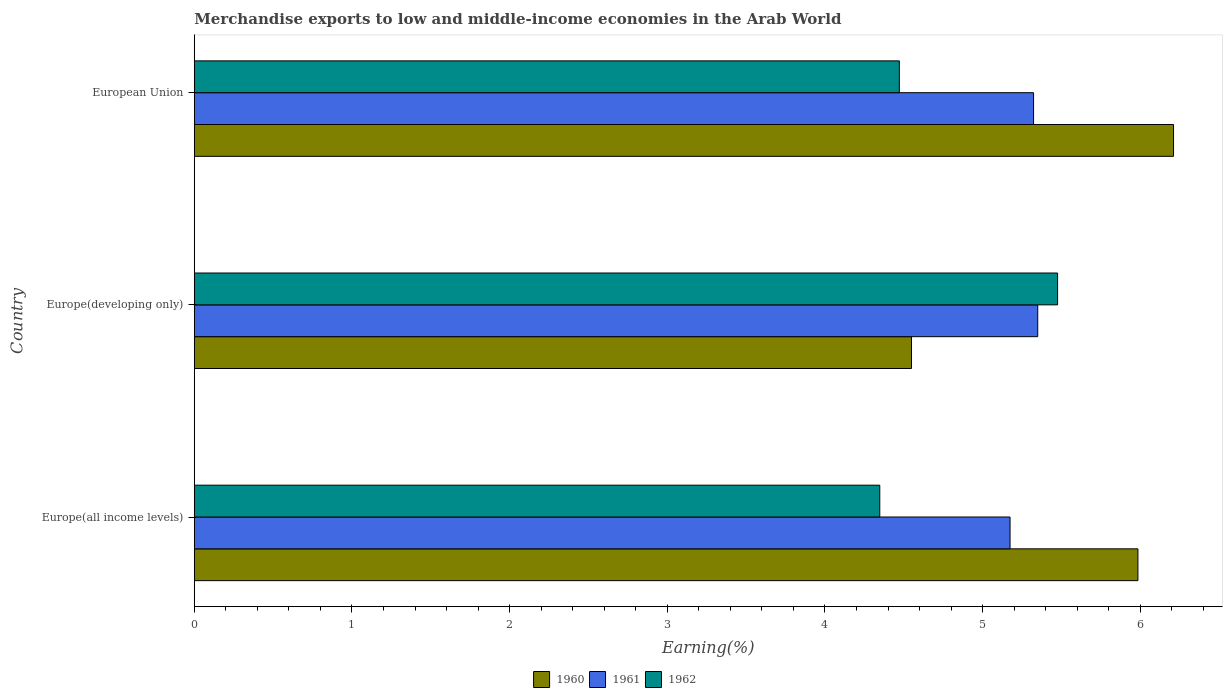How many different coloured bars are there?
Give a very brief answer. 3. How many groups of bars are there?
Provide a succinct answer. 3. Are the number of bars per tick equal to the number of legend labels?
Offer a very short reply. Yes. Are the number of bars on each tick of the Y-axis equal?
Ensure brevity in your answer.  Yes. How many bars are there on the 1st tick from the bottom?
Offer a very short reply. 3. In how many cases, is the number of bars for a given country not equal to the number of legend labels?
Keep it short and to the point. 0. What is the percentage of amount earned from merchandise exports in 1962 in Europe(all income levels)?
Give a very brief answer. 4.35. Across all countries, what is the maximum percentage of amount earned from merchandise exports in 1961?
Offer a very short reply. 5.35. Across all countries, what is the minimum percentage of amount earned from merchandise exports in 1962?
Keep it short and to the point. 4.35. In which country was the percentage of amount earned from merchandise exports in 1960 minimum?
Offer a very short reply. Europe(developing only). What is the total percentage of amount earned from merchandise exports in 1960 in the graph?
Your answer should be compact. 16.74. What is the difference between the percentage of amount earned from merchandise exports in 1960 in Europe(all income levels) and that in Europe(developing only)?
Provide a short and direct response. 1.44. What is the difference between the percentage of amount earned from merchandise exports in 1961 in Europe(developing only) and the percentage of amount earned from merchandise exports in 1962 in Europe(all income levels)?
Make the answer very short. 1. What is the average percentage of amount earned from merchandise exports in 1962 per country?
Offer a very short reply. 4.76. What is the difference between the percentage of amount earned from merchandise exports in 1962 and percentage of amount earned from merchandise exports in 1961 in European Union?
Your response must be concise. -0.85. What is the ratio of the percentage of amount earned from merchandise exports in 1961 in Europe(all income levels) to that in Europe(developing only)?
Provide a succinct answer. 0.97. Is the percentage of amount earned from merchandise exports in 1960 in Europe(all income levels) less than that in Europe(developing only)?
Ensure brevity in your answer.  No. What is the difference between the highest and the second highest percentage of amount earned from merchandise exports in 1962?
Provide a short and direct response. 1. What is the difference between the highest and the lowest percentage of amount earned from merchandise exports in 1962?
Your answer should be very brief. 1.13. Is the sum of the percentage of amount earned from merchandise exports in 1961 in Europe(developing only) and European Union greater than the maximum percentage of amount earned from merchandise exports in 1960 across all countries?
Provide a short and direct response. Yes. What does the 1st bar from the top in European Union represents?
Give a very brief answer. 1962. What does the 1st bar from the bottom in Europe(developing only) represents?
Provide a short and direct response. 1960. Is it the case that in every country, the sum of the percentage of amount earned from merchandise exports in 1960 and percentage of amount earned from merchandise exports in 1961 is greater than the percentage of amount earned from merchandise exports in 1962?
Give a very brief answer. Yes. How many bars are there?
Provide a succinct answer. 9. Are the values on the major ticks of X-axis written in scientific E-notation?
Provide a succinct answer. No. Does the graph contain grids?
Your answer should be very brief. No. Where does the legend appear in the graph?
Keep it short and to the point. Bottom center. How many legend labels are there?
Make the answer very short. 3. What is the title of the graph?
Your response must be concise. Merchandise exports to low and middle-income economies in the Arab World. What is the label or title of the X-axis?
Keep it short and to the point. Earning(%). What is the Earning(%) in 1960 in Europe(all income levels)?
Ensure brevity in your answer.  5.98. What is the Earning(%) in 1961 in Europe(all income levels)?
Offer a terse response. 5.17. What is the Earning(%) in 1962 in Europe(all income levels)?
Your answer should be compact. 4.35. What is the Earning(%) in 1960 in Europe(developing only)?
Offer a very short reply. 4.55. What is the Earning(%) of 1961 in Europe(developing only)?
Provide a succinct answer. 5.35. What is the Earning(%) of 1962 in Europe(developing only)?
Offer a terse response. 5.48. What is the Earning(%) in 1960 in European Union?
Your response must be concise. 6.21. What is the Earning(%) of 1961 in European Union?
Keep it short and to the point. 5.32. What is the Earning(%) in 1962 in European Union?
Your response must be concise. 4.47. Across all countries, what is the maximum Earning(%) in 1960?
Your answer should be very brief. 6.21. Across all countries, what is the maximum Earning(%) in 1961?
Your response must be concise. 5.35. Across all countries, what is the maximum Earning(%) of 1962?
Keep it short and to the point. 5.48. Across all countries, what is the minimum Earning(%) of 1960?
Provide a succinct answer. 4.55. Across all countries, what is the minimum Earning(%) in 1961?
Your response must be concise. 5.17. Across all countries, what is the minimum Earning(%) of 1962?
Your response must be concise. 4.35. What is the total Earning(%) of 1960 in the graph?
Make the answer very short. 16.74. What is the total Earning(%) of 1961 in the graph?
Provide a short and direct response. 15.85. What is the total Earning(%) of 1962 in the graph?
Give a very brief answer. 14.29. What is the difference between the Earning(%) of 1960 in Europe(all income levels) and that in Europe(developing only)?
Provide a short and direct response. 1.44. What is the difference between the Earning(%) of 1961 in Europe(all income levels) and that in Europe(developing only)?
Provide a succinct answer. -0.18. What is the difference between the Earning(%) of 1962 in Europe(all income levels) and that in Europe(developing only)?
Your answer should be very brief. -1.13. What is the difference between the Earning(%) in 1960 in Europe(all income levels) and that in European Union?
Keep it short and to the point. -0.23. What is the difference between the Earning(%) of 1961 in Europe(all income levels) and that in European Union?
Your response must be concise. -0.15. What is the difference between the Earning(%) in 1962 in Europe(all income levels) and that in European Union?
Offer a very short reply. -0.12. What is the difference between the Earning(%) of 1960 in Europe(developing only) and that in European Union?
Ensure brevity in your answer.  -1.66. What is the difference between the Earning(%) in 1961 in Europe(developing only) and that in European Union?
Provide a short and direct response. 0.03. What is the difference between the Earning(%) in 1962 in Europe(developing only) and that in European Union?
Provide a short and direct response. 1. What is the difference between the Earning(%) in 1960 in Europe(all income levels) and the Earning(%) in 1961 in Europe(developing only)?
Provide a succinct answer. 0.64. What is the difference between the Earning(%) in 1960 in Europe(all income levels) and the Earning(%) in 1962 in Europe(developing only)?
Keep it short and to the point. 0.51. What is the difference between the Earning(%) of 1961 in Europe(all income levels) and the Earning(%) of 1962 in Europe(developing only)?
Ensure brevity in your answer.  -0.3. What is the difference between the Earning(%) of 1960 in Europe(all income levels) and the Earning(%) of 1961 in European Union?
Give a very brief answer. 0.66. What is the difference between the Earning(%) in 1960 in Europe(all income levels) and the Earning(%) in 1962 in European Union?
Provide a short and direct response. 1.51. What is the difference between the Earning(%) of 1961 in Europe(all income levels) and the Earning(%) of 1962 in European Union?
Give a very brief answer. 0.7. What is the difference between the Earning(%) in 1960 in Europe(developing only) and the Earning(%) in 1961 in European Union?
Your response must be concise. -0.77. What is the difference between the Earning(%) in 1960 in Europe(developing only) and the Earning(%) in 1962 in European Union?
Keep it short and to the point. 0.08. What is the difference between the Earning(%) of 1961 in Europe(developing only) and the Earning(%) of 1962 in European Union?
Your response must be concise. 0.88. What is the average Earning(%) of 1960 per country?
Your answer should be very brief. 5.58. What is the average Earning(%) of 1961 per country?
Your answer should be compact. 5.28. What is the average Earning(%) in 1962 per country?
Provide a short and direct response. 4.76. What is the difference between the Earning(%) of 1960 and Earning(%) of 1961 in Europe(all income levels)?
Keep it short and to the point. 0.81. What is the difference between the Earning(%) of 1960 and Earning(%) of 1962 in Europe(all income levels)?
Offer a very short reply. 1.64. What is the difference between the Earning(%) of 1961 and Earning(%) of 1962 in Europe(all income levels)?
Offer a very short reply. 0.83. What is the difference between the Earning(%) of 1960 and Earning(%) of 1961 in Europe(developing only)?
Ensure brevity in your answer.  -0.8. What is the difference between the Earning(%) in 1960 and Earning(%) in 1962 in Europe(developing only)?
Offer a terse response. -0.93. What is the difference between the Earning(%) of 1961 and Earning(%) of 1962 in Europe(developing only)?
Give a very brief answer. -0.13. What is the difference between the Earning(%) of 1960 and Earning(%) of 1961 in European Union?
Ensure brevity in your answer.  0.89. What is the difference between the Earning(%) in 1960 and Earning(%) in 1962 in European Union?
Your answer should be compact. 1.74. What is the difference between the Earning(%) in 1961 and Earning(%) in 1962 in European Union?
Keep it short and to the point. 0.85. What is the ratio of the Earning(%) in 1960 in Europe(all income levels) to that in Europe(developing only)?
Your response must be concise. 1.32. What is the ratio of the Earning(%) in 1961 in Europe(all income levels) to that in Europe(developing only)?
Provide a short and direct response. 0.97. What is the ratio of the Earning(%) in 1962 in Europe(all income levels) to that in Europe(developing only)?
Your response must be concise. 0.79. What is the ratio of the Earning(%) of 1960 in Europe(all income levels) to that in European Union?
Your response must be concise. 0.96. What is the ratio of the Earning(%) of 1961 in Europe(all income levels) to that in European Union?
Offer a very short reply. 0.97. What is the ratio of the Earning(%) of 1962 in Europe(all income levels) to that in European Union?
Keep it short and to the point. 0.97. What is the ratio of the Earning(%) in 1960 in Europe(developing only) to that in European Union?
Your response must be concise. 0.73. What is the ratio of the Earning(%) of 1962 in Europe(developing only) to that in European Union?
Make the answer very short. 1.22. What is the difference between the highest and the second highest Earning(%) in 1960?
Offer a terse response. 0.23. What is the difference between the highest and the second highest Earning(%) in 1961?
Your response must be concise. 0.03. What is the difference between the highest and the second highest Earning(%) of 1962?
Ensure brevity in your answer.  1. What is the difference between the highest and the lowest Earning(%) of 1960?
Give a very brief answer. 1.66. What is the difference between the highest and the lowest Earning(%) in 1961?
Keep it short and to the point. 0.18. What is the difference between the highest and the lowest Earning(%) of 1962?
Provide a short and direct response. 1.13. 